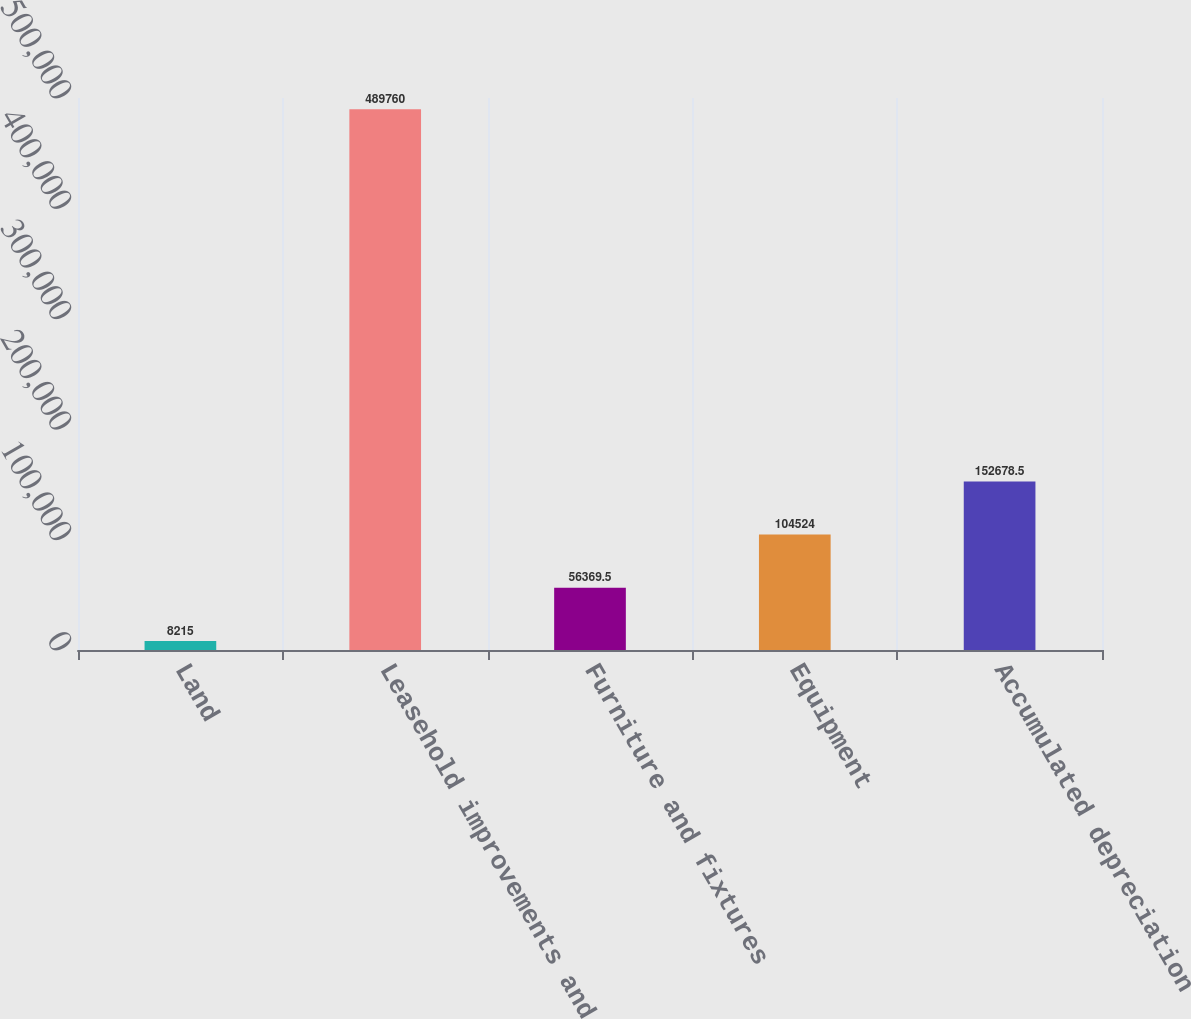Convert chart. <chart><loc_0><loc_0><loc_500><loc_500><bar_chart><fcel>Land<fcel>Leasehold improvements and<fcel>Furniture and fixtures<fcel>Equipment<fcel>Accumulated depreciation<nl><fcel>8215<fcel>489760<fcel>56369.5<fcel>104524<fcel>152678<nl></chart> 